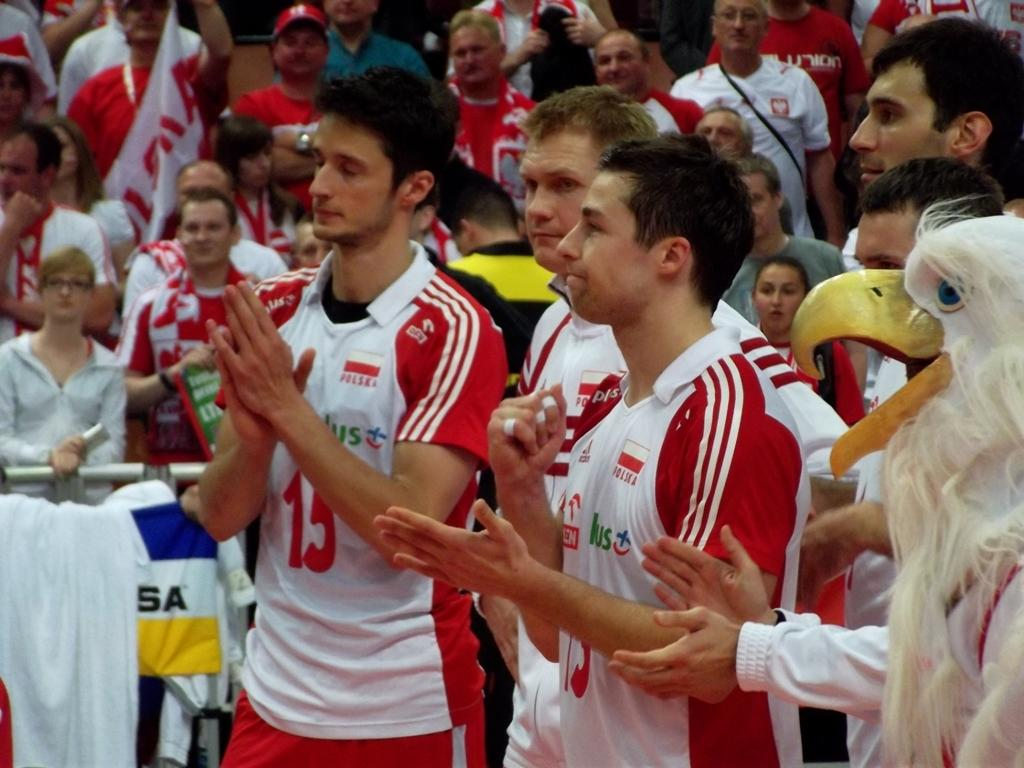<image>
Share a concise interpretation of the image provided. A group of soccer players are clapping and one of their shirts has a 15 on it. 